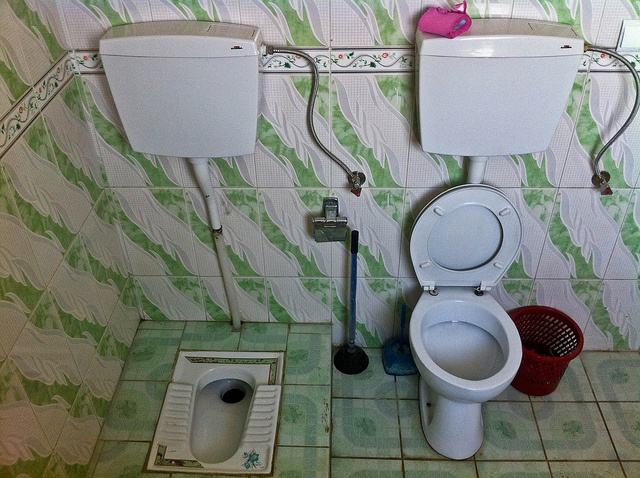Describe the objects in this image and their specific colors. I can see toilet in gray, darkgray, and lightgray tones and toilet in gray and black tones in this image. 